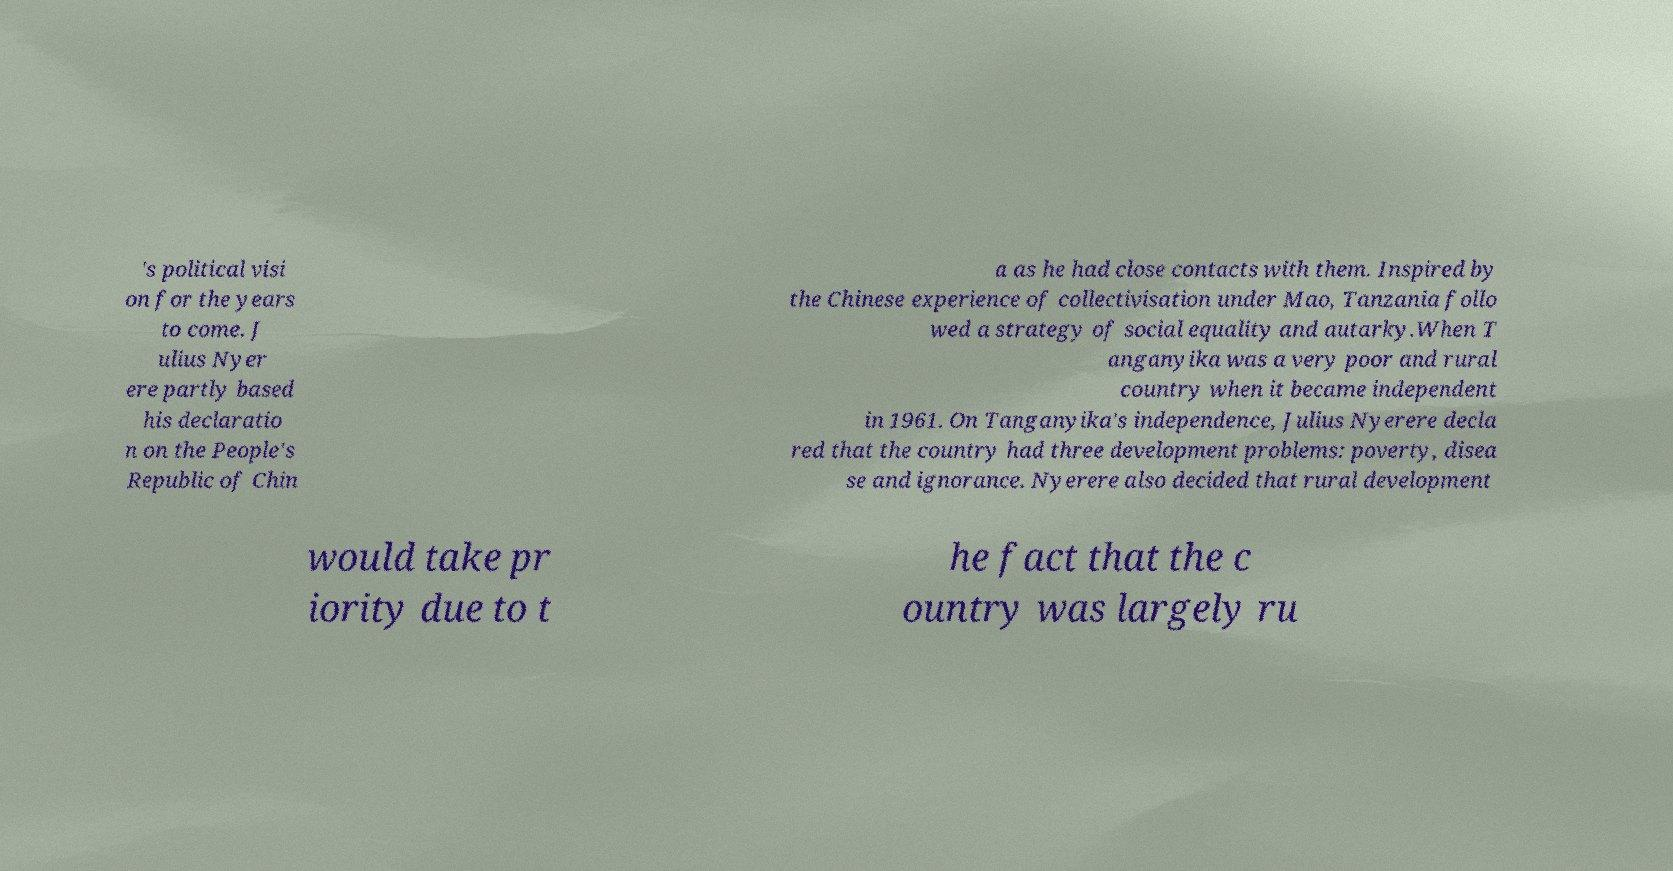I need the written content from this picture converted into text. Can you do that? 's political visi on for the years to come. J ulius Nyer ere partly based his declaratio n on the People's Republic of Chin a as he had close contacts with them. Inspired by the Chinese experience of collectivisation under Mao, Tanzania follo wed a strategy of social equality and autarky.When T anganyika was a very poor and rural country when it became independent in 1961. On Tanganyika's independence, Julius Nyerere decla red that the country had three development problems: poverty, disea se and ignorance. Nyerere also decided that rural development would take pr iority due to t he fact that the c ountry was largely ru 